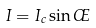Convert formula to latex. <formula><loc_0><loc_0><loc_500><loc_500>I = I _ { c } \sin \phi</formula> 